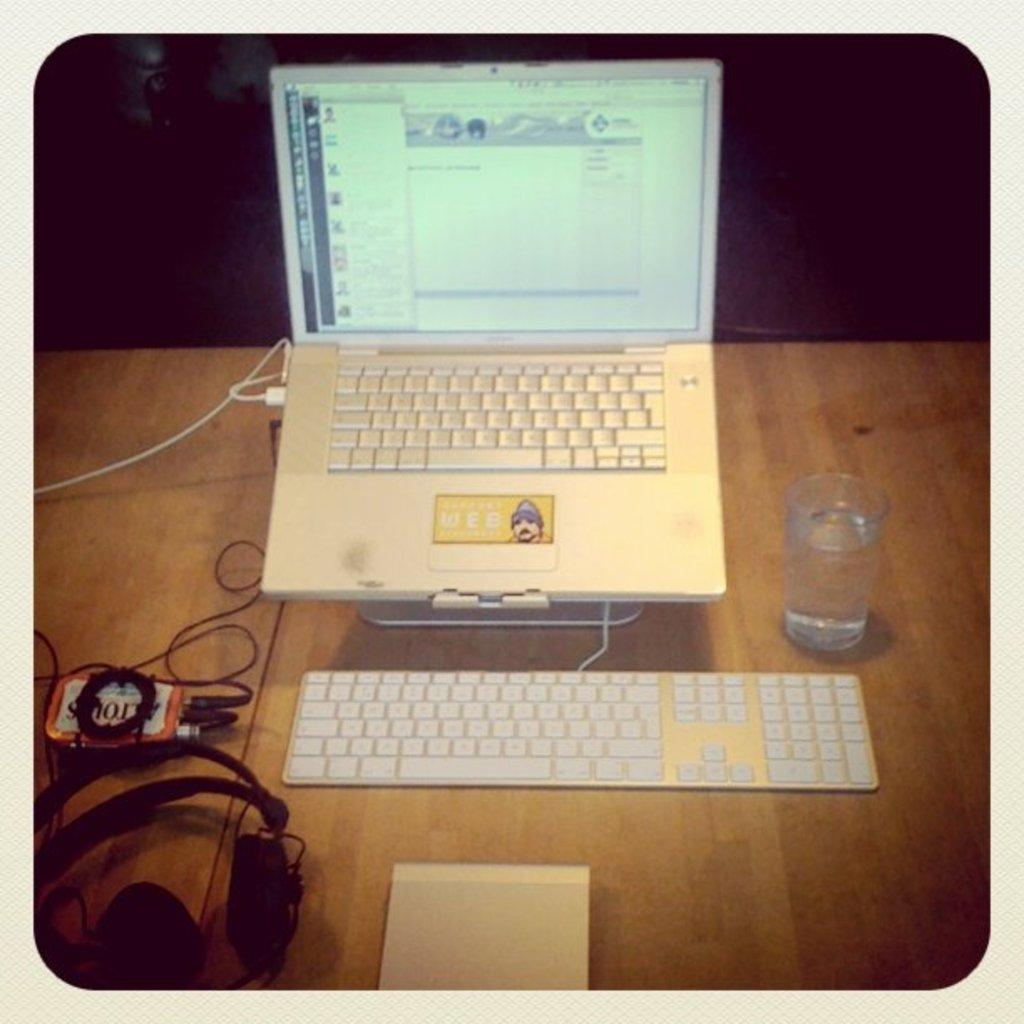<image>
Present a compact description of the photo's key features. Old laptop sits on a wooden top the mouse pad say web. 